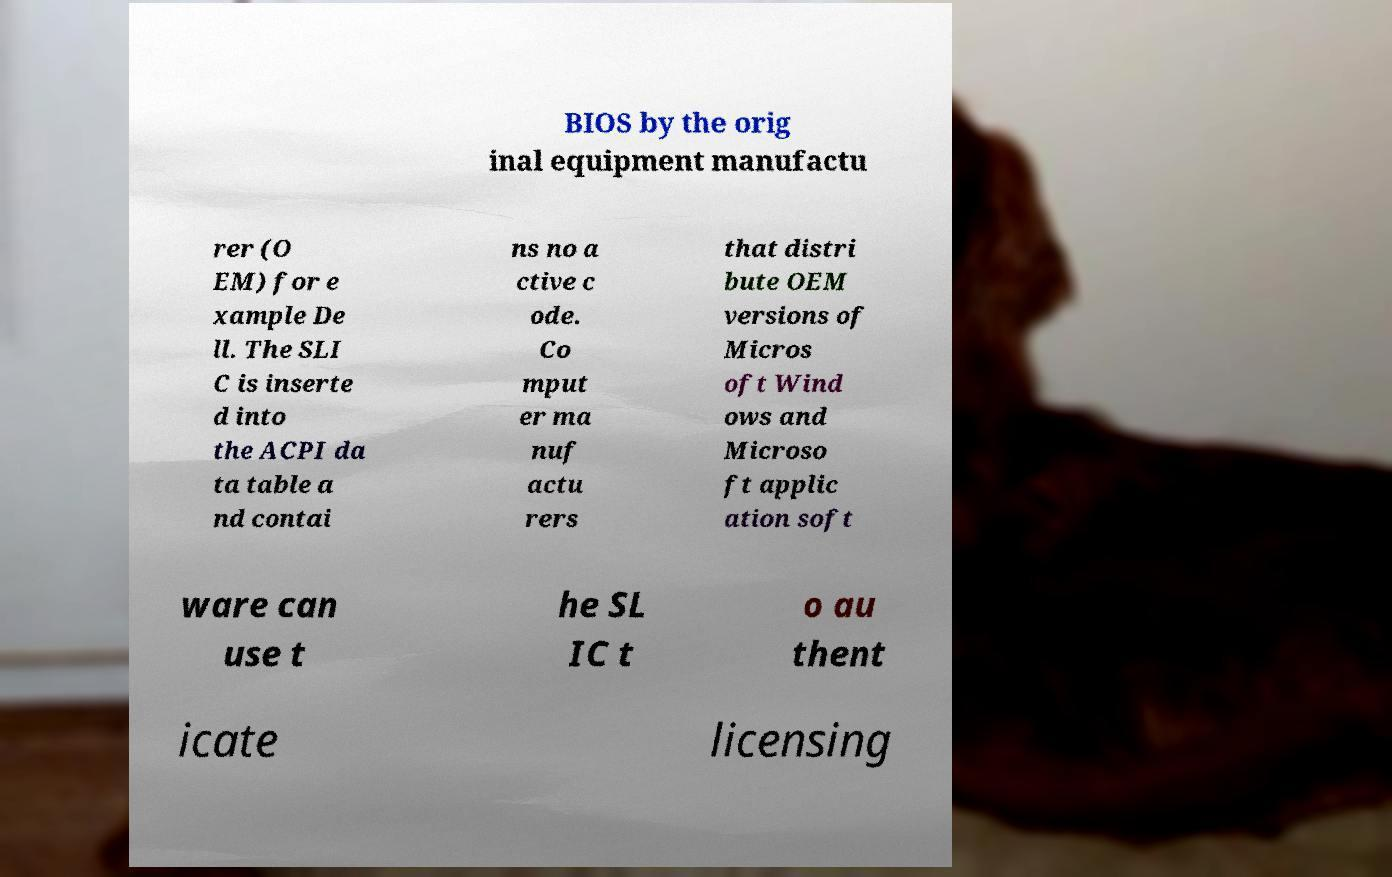Can you accurately transcribe the text from the provided image for me? BIOS by the orig inal equipment manufactu rer (O EM) for e xample De ll. The SLI C is inserte d into the ACPI da ta table a nd contai ns no a ctive c ode. Co mput er ma nuf actu rers that distri bute OEM versions of Micros oft Wind ows and Microso ft applic ation soft ware can use t he SL IC t o au thent icate licensing 